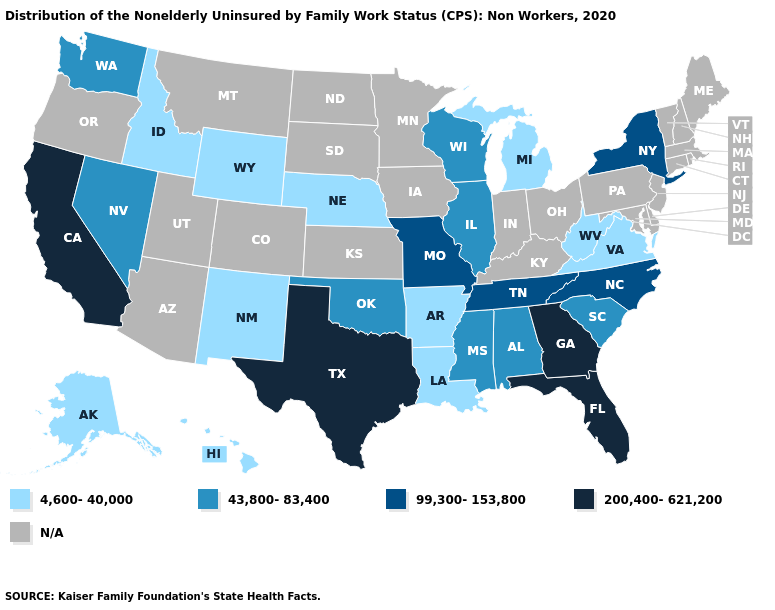Name the states that have a value in the range N/A?
Concise answer only. Arizona, Colorado, Connecticut, Delaware, Indiana, Iowa, Kansas, Kentucky, Maine, Maryland, Massachusetts, Minnesota, Montana, New Hampshire, New Jersey, North Dakota, Ohio, Oregon, Pennsylvania, Rhode Island, South Dakota, Utah, Vermont. What is the highest value in states that border New Mexico?
Answer briefly. 200,400-621,200. Among the states that border Nebraska , does Missouri have the lowest value?
Short answer required. No. Which states hav the highest value in the Northeast?
Give a very brief answer. New York. Name the states that have a value in the range 43,800-83,400?
Short answer required. Alabama, Illinois, Mississippi, Nevada, Oklahoma, South Carolina, Washington, Wisconsin. Which states have the highest value in the USA?
Write a very short answer. California, Florida, Georgia, Texas. What is the value of Michigan?
Write a very short answer. 4,600-40,000. Name the states that have a value in the range N/A?
Quick response, please. Arizona, Colorado, Connecticut, Delaware, Indiana, Iowa, Kansas, Kentucky, Maine, Maryland, Massachusetts, Minnesota, Montana, New Hampshire, New Jersey, North Dakota, Ohio, Oregon, Pennsylvania, Rhode Island, South Dakota, Utah, Vermont. Name the states that have a value in the range 43,800-83,400?
Quick response, please. Alabama, Illinois, Mississippi, Nevada, Oklahoma, South Carolina, Washington, Wisconsin. What is the lowest value in the Northeast?
Be succinct. 99,300-153,800. What is the value of Alaska?
Concise answer only. 4,600-40,000. What is the value of Hawaii?
Answer briefly. 4,600-40,000. Name the states that have a value in the range 4,600-40,000?
Keep it brief. Alaska, Arkansas, Hawaii, Idaho, Louisiana, Michigan, Nebraska, New Mexico, Virginia, West Virginia, Wyoming. 